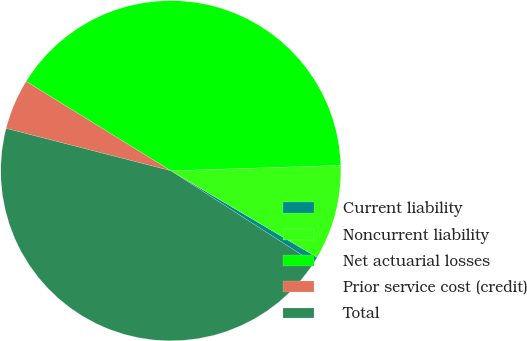Convert chart to OTSL. <chart><loc_0><loc_0><loc_500><loc_500><pie_chart><fcel>Current liability<fcel>Noncurrent liability<fcel>Net actuarial losses<fcel>Prior service cost (credit)<fcel>Total<nl><fcel>0.59%<fcel>9.01%<fcel>40.69%<fcel>4.8%<fcel>44.9%<nl></chart> 